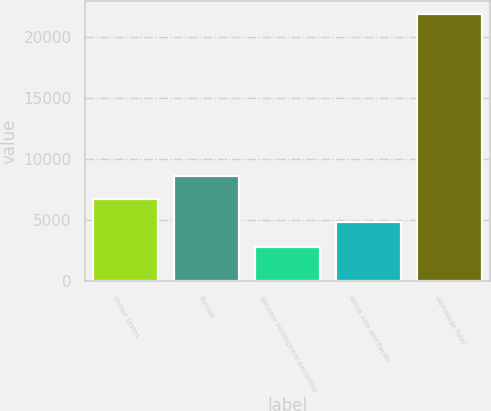<chart> <loc_0><loc_0><loc_500><loc_500><bar_chart><fcel>United States<fcel>Europe<fcel>Western Hemisphere excluding<fcel>Africa Asia and Pacific<fcel>Worldwide Total<nl><fcel>6741.3<fcel>8648.6<fcel>2800<fcel>4834<fcel>21873<nl></chart> 